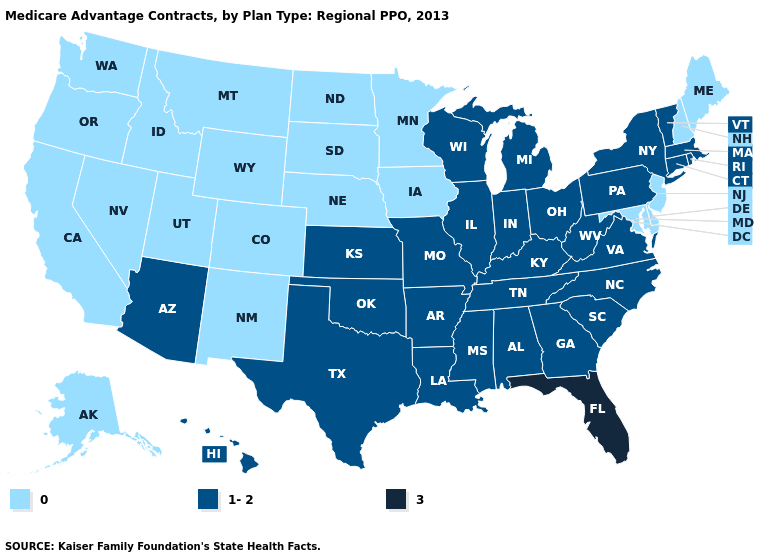Which states have the highest value in the USA?
Keep it brief. Florida. Name the states that have a value in the range 3?
Answer briefly. Florida. Name the states that have a value in the range 3?
Keep it brief. Florida. What is the value of Montana?
Give a very brief answer. 0. Does Kansas have the lowest value in the MidWest?
Give a very brief answer. No. Name the states that have a value in the range 0?
Be succinct. Alaska, California, Colorado, Delaware, Iowa, Idaho, Maryland, Maine, Minnesota, Montana, North Dakota, Nebraska, New Hampshire, New Jersey, New Mexico, Nevada, Oregon, South Dakota, Utah, Washington, Wyoming. Name the states that have a value in the range 3?
Concise answer only. Florida. Does Alabama have a lower value than Iowa?
Concise answer only. No. Which states have the highest value in the USA?
Be succinct. Florida. What is the value of Rhode Island?
Be succinct. 1-2. Which states have the lowest value in the MidWest?
Concise answer only. Iowa, Minnesota, North Dakota, Nebraska, South Dakota. What is the lowest value in the USA?
Keep it brief. 0. What is the lowest value in the USA?
Be succinct. 0. Does the first symbol in the legend represent the smallest category?
Short answer required. Yes. Does Alaska have the lowest value in the USA?
Answer briefly. Yes. 